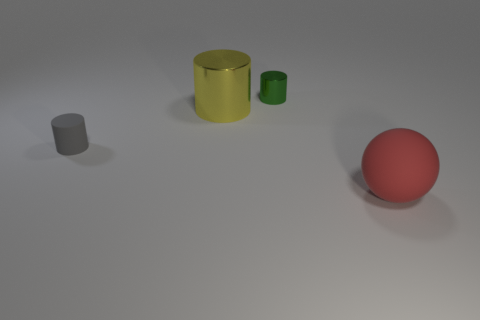Add 1 green metal cylinders. How many objects exist? 5 Subtract all spheres. How many objects are left? 3 Subtract 0 purple balls. How many objects are left? 4 Subtract all gray matte objects. Subtract all small green things. How many objects are left? 2 Add 1 big things. How many big things are left? 3 Add 3 large gray shiny objects. How many large gray shiny objects exist? 3 